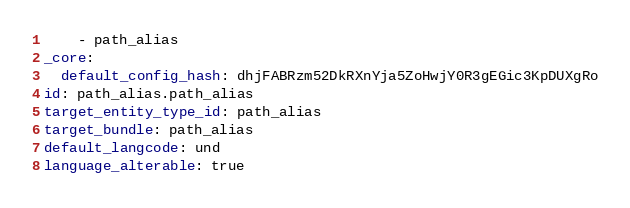Convert code to text. <code><loc_0><loc_0><loc_500><loc_500><_YAML_>    - path_alias
_core:
  default_config_hash: dhjFABRzm52DkRXnYja5ZoHwjY0R3gEGic3KpDUXgRo
id: path_alias.path_alias
target_entity_type_id: path_alias
target_bundle: path_alias
default_langcode: und
language_alterable: true
</code> 